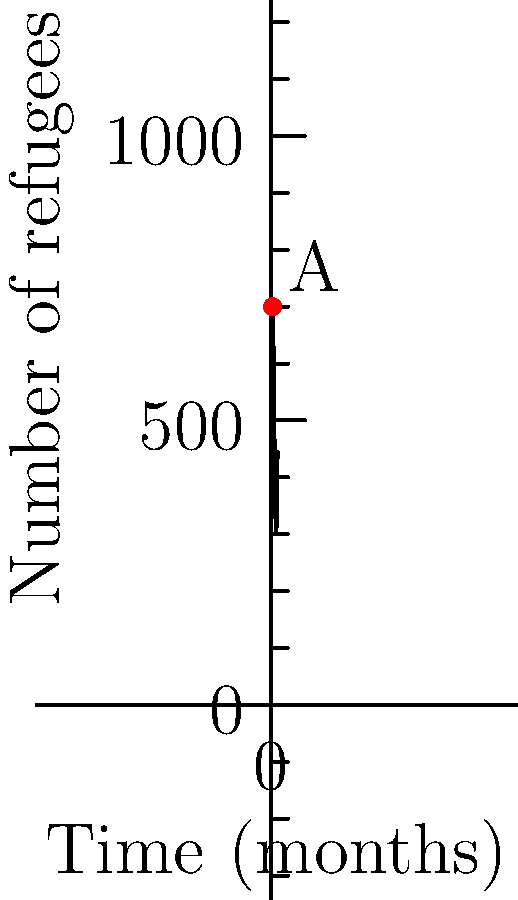The graph shows the number of refugee arrivals over a 12-month period. At point A, which occurs at $t = \pi$ months, what is the instantaneous rate of change of refugee arrivals? To find the instantaneous rate of change at point A, we need to calculate the derivative of the function at $t = \pi$.

1) The function representing the number of refugees is:
   $f(t) = 500 + 200\sin(\frac{t}{2})$

2) To find the rate of change, we need to differentiate $f(t)$:
   $f'(t) = 200 \cdot \frac{1}{2} \cos(\frac{t}{2}) = 100\cos(\frac{t}{2})$

3) Now, we evaluate $f'(t)$ at $t = \pi$:
   $f'(\pi) = 100\cos(\frac{\pi}{2}) = 100 \cdot 0 = 0$

4) The instantaneous rate of change at point A is 0 refugees per month.

This means that at exactly $\pi$ months, the number of refugee arrivals is neither increasing nor decreasing.
Answer: 0 refugees/month 